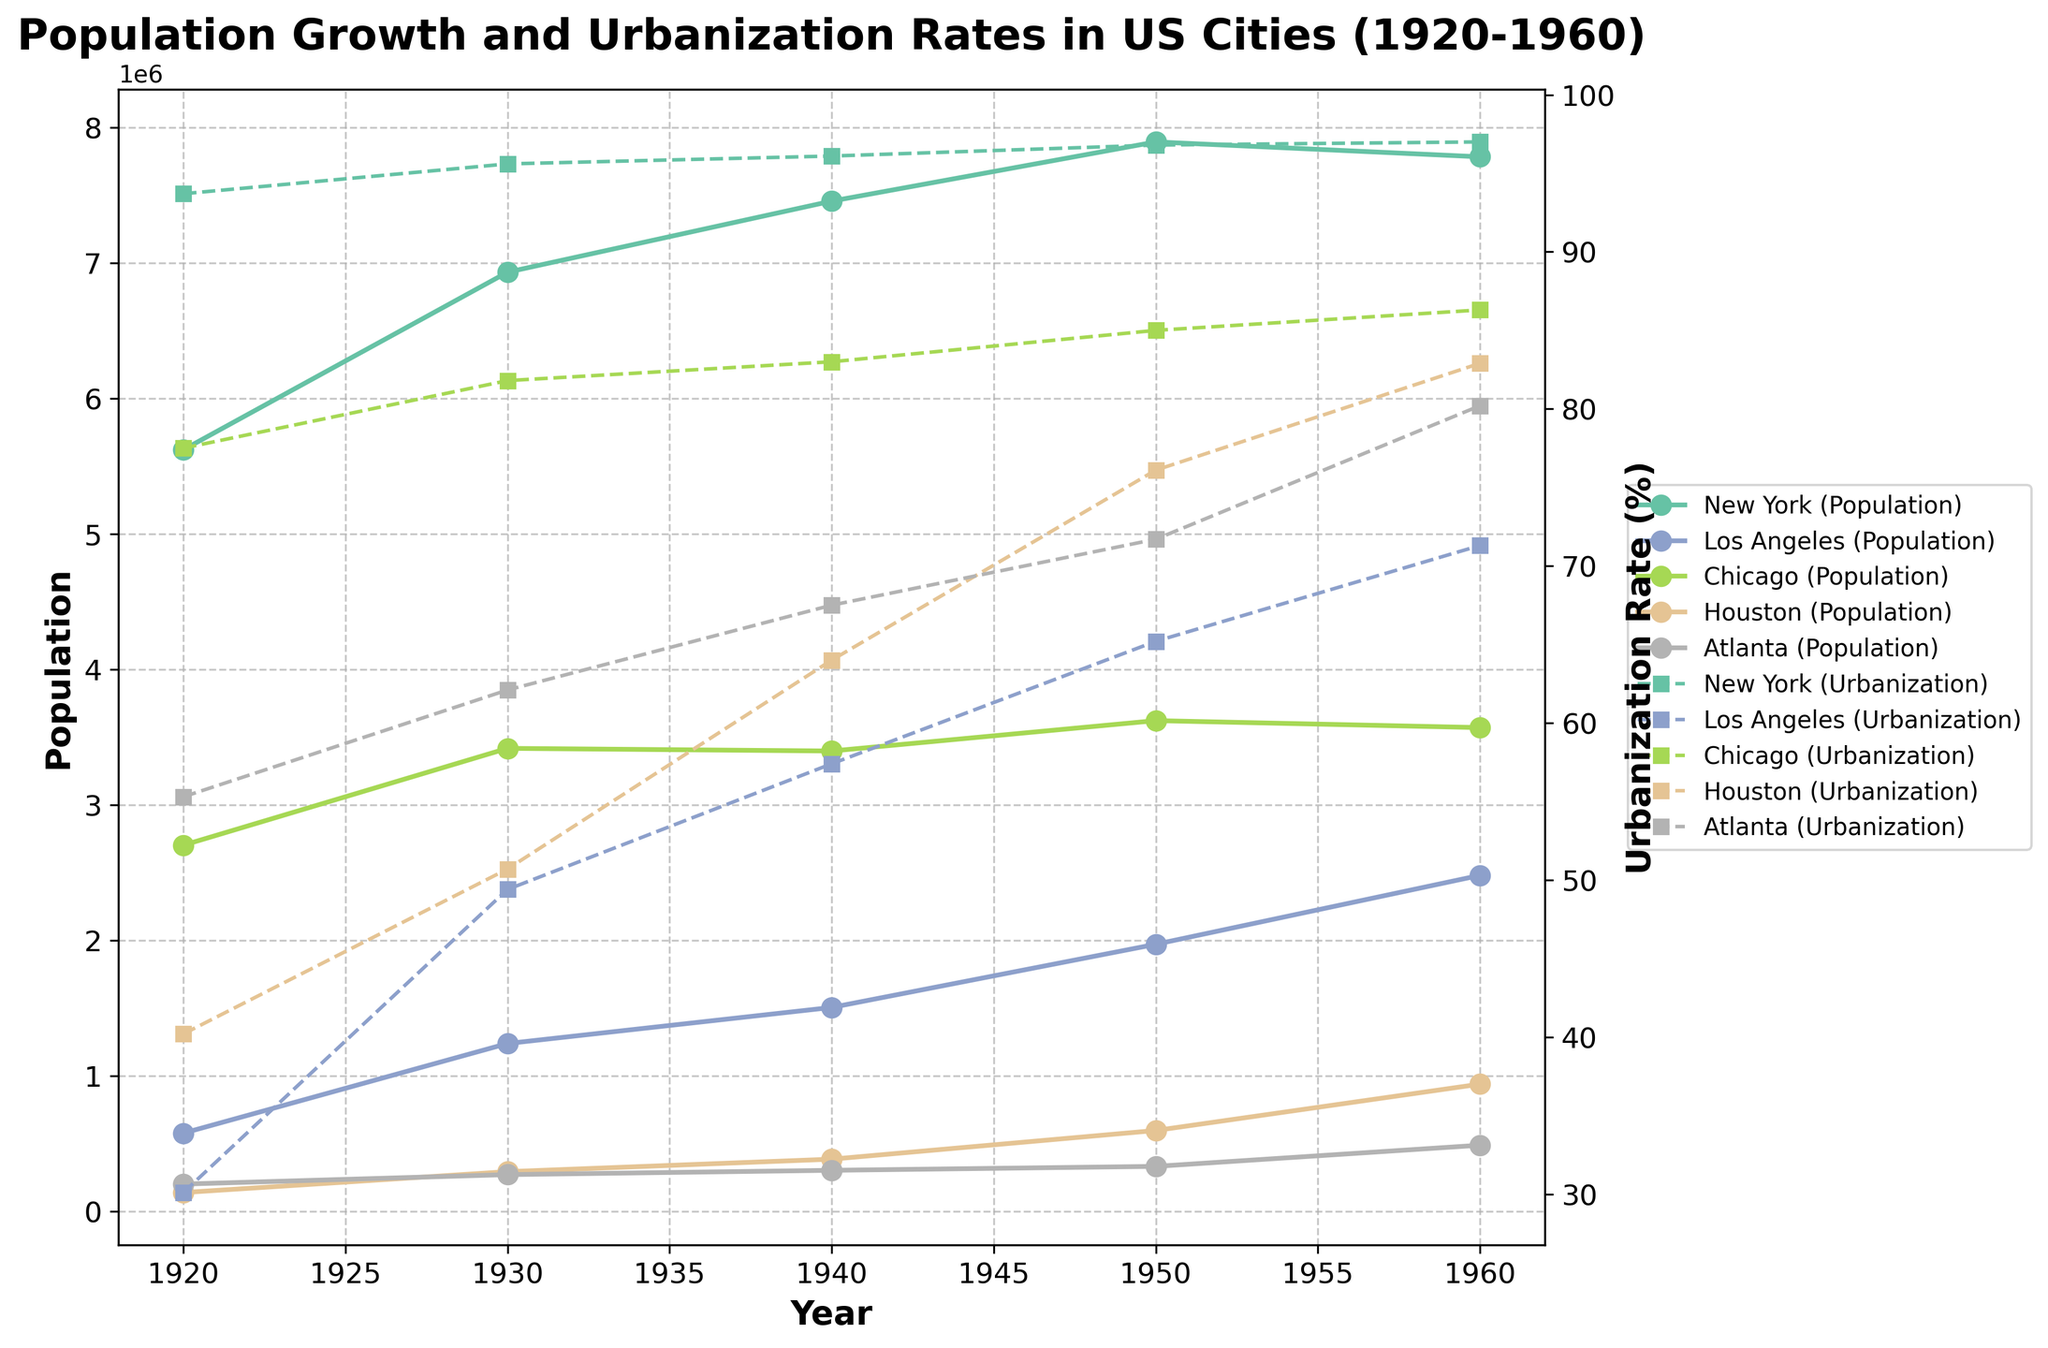What are the colors used for New York's data points? New York's data points are colored for both the population and urbanization rate lines. The color appears consistent for both data series, indicating the same color is used across these two representations. This allows easy identification and differentiation from other cities.
Answer: Likely green (based on color schemes commonly used for multiple-line plots) What is the range of years covered in this figure? The x-axis at the bottom of the figure represents the range of years covered. The data points start from the left at 1920 and go to the right until 1960.
Answer: 1920 to 1960 Which city had the highest population growth between 1920 and 1960? Examining the lines representing population growth, Los Angeles shows a significant rise. Starting with 576,673 in 1920 and reaching 2,479,015 in 1960, it has the steepest upward trend among all the cities.
Answer: Los Angeles How did Houston's urbanization rate change from 1920 to 1960? The dashed line for Houston's urbanization rate increases over the years. It starts at 40.2% in 1920 and rises to 82.9% in 1960. Checking each interval confirms the steady ascent.
Answer: Increased from 40.2% to 82.9% What is the population of Chicago in 1950? Find the data point on the solid line for Chicago at the year 1950. The value reads approximately 3,620,962.
Answer: 3,620,962 Which city had the lowest urbanization rate in 1940? Look at the year 1940 on the x-axis and check all dashed lines' values. Los Angeles has the lowest peak among them, indicating its urbanization rate.
Answer: Los Angeles Which city shows the most noticeable difference between population and urbanization trends? Los Angeles features a large difference, with a rapidly increasing population but a gradually rising urbanization rate. This contrast is visually significant due to the steep slope of the population line compared to the urbanization rate line.
Answer: Los Angeles How did New York's urbanization rate compare with Atlanta's in 1960? At the year 1960 on the x-axis, compare the values of the dashed lines for New York and Atlanta. New York's urbanization rate is around 97.0%, whereas Atlanta's rate is approximately 80.2%.
Answer: New York is higher What trend can be observed in Atlanta's population from 1920 to 1960? Track the population (solid) line for Atlanta across the figure. Each value shows a steady and consistent increase over time, from 200,616 in 1920 to 487,455 in 1960.
Answer: Steady increase Which city had the most stable urbanization rate across the time period? Urbanization rates show through dashed lines for each city. Chicago's line shows the least fluctuation comparatively, remaining relatively high and constant.
Answer: Chicago 